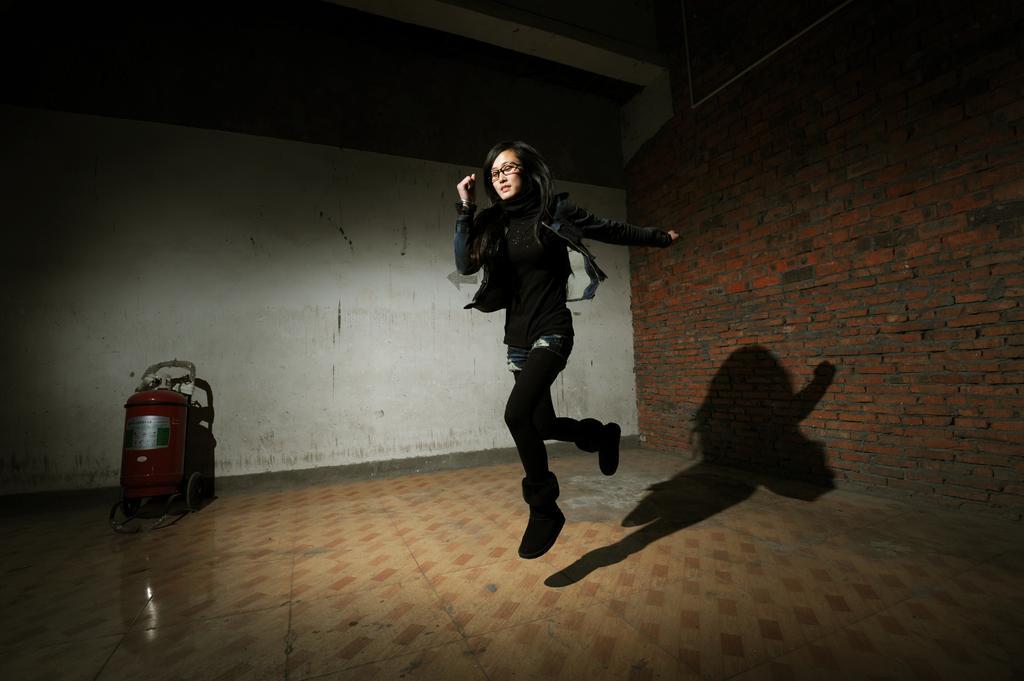Describe this image in one or two sentences. In this image I can see a woman. I can see something on the floor. In the background, I can see the wall. 